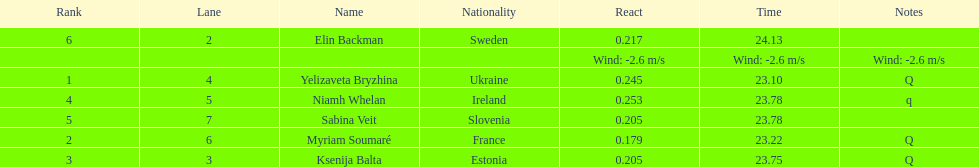The difference between yelizaveta bryzhina's time and ksenija balta's time? 0.65. 